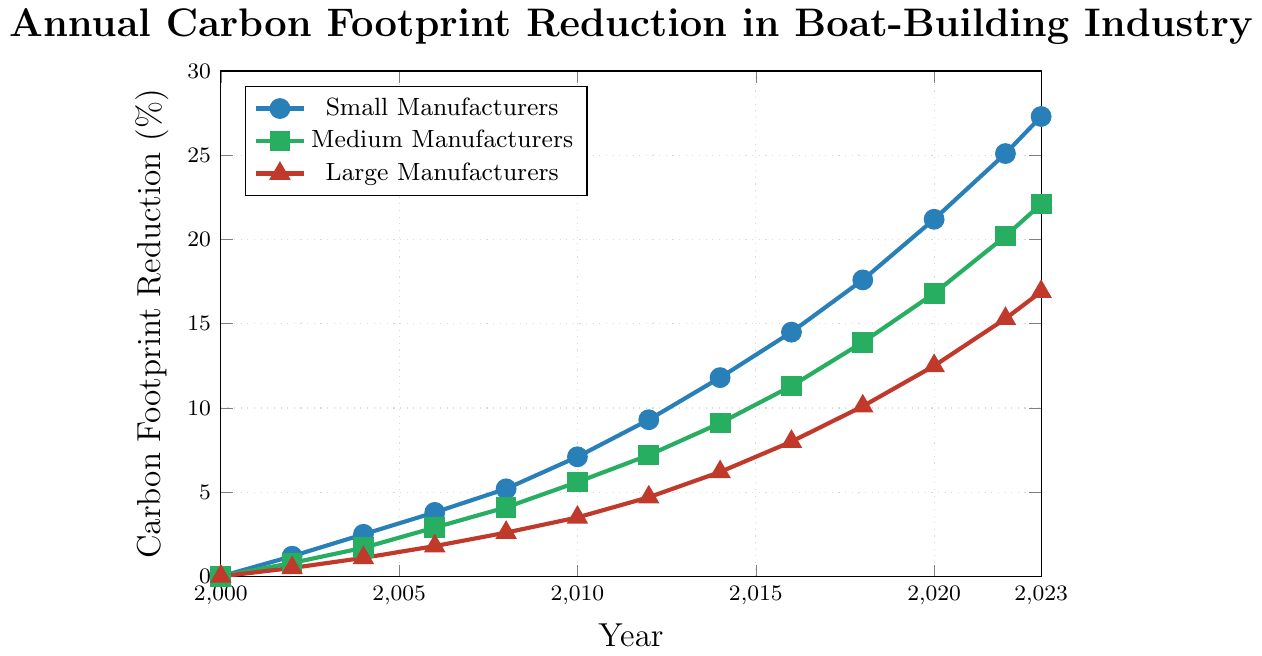What is the difference in carbon footprint reduction between small and large manufacturers in 2023? In 2023, the carbon footprint reduction for small manufacturers is 27.3% and for large manufacturers is 16.9%. The difference is calculated by subtracting 16.9 from 27.3.
Answer: 10.4% Between which years did small manufacturers see the highest increase in carbon footprint reduction? To find this, we look at the increase in reduction between each data point for small manufacturers by subtracting the previous year's reduction from the current year's reduction. The highest increase is between 2020 (21.2%) and 2022 (25.1%), which is 3.9%.
Answer: 2020 to 2022 What is the average annual carbon footprint reduction for medium manufacturers between 2010 and 2020? We need to find the reductions in 2010, 2012, 2014, 2016, 2018, and 2020, sum them up, and divide by the number of years. The reductions are 5.6%, 7.2%, 9.1%, 11.3%, 13.9%, and 16.8%. Sum is 63.9. Dividing by 6, we get 63.9 / 6.
Answer: 10.65% Which manufacturer type had the smallest total carbon footprint reduction by the year 2023? By summing the carbon footprint reductions from 2000 to 2023 for each type, we find the smallest summation corresponds to the data points for large manufacturers.
Answer: Large Manufacturers How does the growth in carbon footprint reduction from 2002 to 2008 compare between small and medium manufacturers? For small manufacturers, the increase from 2002 to 2008 is 5.2 - 1.2 = 4 percentage points. For medium manufacturers, the increase is 4.1 - 0.8 = 3.3 percentage points.
Answer: Small manufacturers increased more by 0.9% What is the visual pattern of the line representing medium manufacturers? The green line representing medium manufacturers shows a steadily increasing trend with no periods of decline from 2000 to 2023. This indicates consistent progress in carbon footprint reduction.
Answer: Steadily increasing At which year did small manufacturers' carbon footprint reduction first exceed 10%? By examining the data points for small manufacturers, they first exceed 10% in the year 2014 with a value of 11.8%.
Answer: 2014 Which manufacturer type had the most gradual increase in carbon footprint reduction from 2000 to 2023? By observing the slopes of each line, the red line representing large manufacturers shows the most gradual increase, indicating the slowest rate of carbon footprint reduction.
Answer: Large Manufacturers 